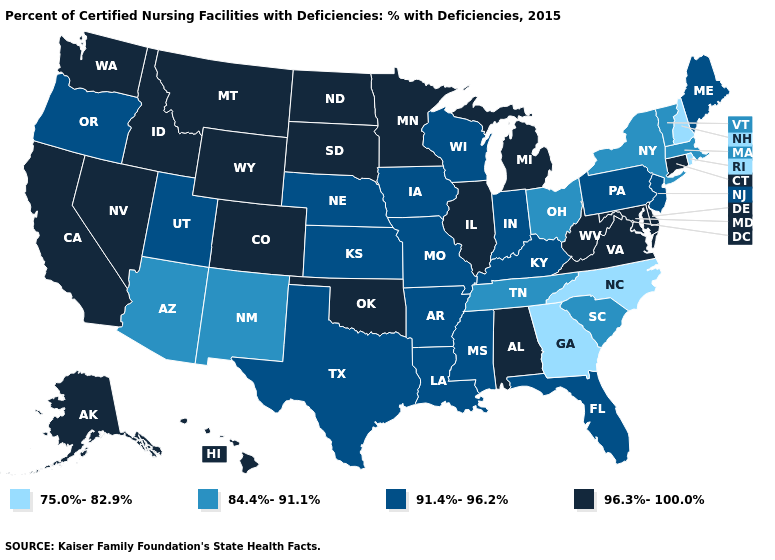What is the highest value in the Northeast ?
Quick response, please. 96.3%-100.0%. What is the highest value in the USA?
Answer briefly. 96.3%-100.0%. Name the states that have a value in the range 84.4%-91.1%?
Answer briefly. Arizona, Massachusetts, New Mexico, New York, Ohio, South Carolina, Tennessee, Vermont. Does Minnesota have the highest value in the USA?
Answer briefly. Yes. Which states have the lowest value in the USA?
Short answer required. Georgia, New Hampshire, North Carolina, Rhode Island. What is the lowest value in the USA?
Keep it brief. 75.0%-82.9%. What is the value of Florida?
Give a very brief answer. 91.4%-96.2%. Does Idaho have a higher value than North Dakota?
Give a very brief answer. No. Which states have the lowest value in the MidWest?
Be succinct. Ohio. What is the highest value in the Northeast ?
Answer briefly. 96.3%-100.0%. What is the value of Hawaii?
Short answer required. 96.3%-100.0%. What is the lowest value in the USA?
Answer briefly. 75.0%-82.9%. Name the states that have a value in the range 75.0%-82.9%?
Write a very short answer. Georgia, New Hampshire, North Carolina, Rhode Island. Does North Dakota have the highest value in the MidWest?
Be succinct. Yes. What is the highest value in the USA?
Be succinct. 96.3%-100.0%. 